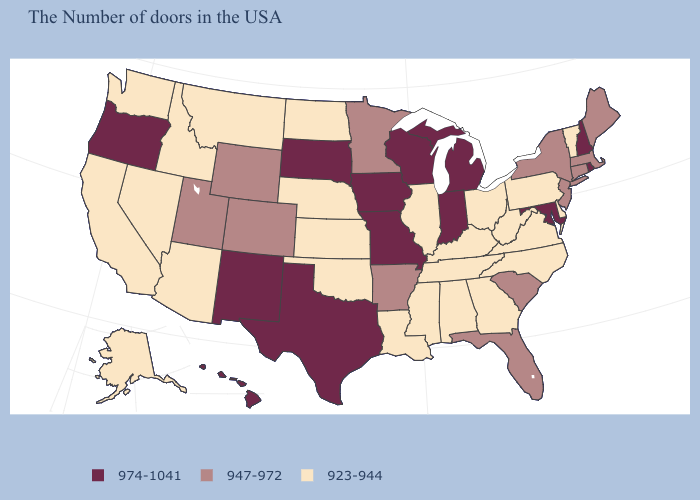Which states have the highest value in the USA?
Concise answer only. Rhode Island, New Hampshire, Maryland, Michigan, Indiana, Wisconsin, Missouri, Iowa, Texas, South Dakota, New Mexico, Oregon, Hawaii. What is the value of California?
Short answer required. 923-944. Does Washington have the highest value in the USA?
Give a very brief answer. No. What is the value of Kansas?
Write a very short answer. 923-944. What is the value of Nebraska?
Give a very brief answer. 923-944. Among the states that border Pennsylvania , which have the lowest value?
Be succinct. Delaware, West Virginia, Ohio. Among the states that border Washington , does Idaho have the lowest value?
Short answer required. Yes. What is the value of Alaska?
Quick response, please. 923-944. Name the states that have a value in the range 923-944?
Write a very short answer. Vermont, Delaware, Pennsylvania, Virginia, North Carolina, West Virginia, Ohio, Georgia, Kentucky, Alabama, Tennessee, Illinois, Mississippi, Louisiana, Kansas, Nebraska, Oklahoma, North Dakota, Montana, Arizona, Idaho, Nevada, California, Washington, Alaska. Among the states that border New York , which have the highest value?
Be succinct. Massachusetts, Connecticut, New Jersey. Name the states that have a value in the range 974-1041?
Give a very brief answer. Rhode Island, New Hampshire, Maryland, Michigan, Indiana, Wisconsin, Missouri, Iowa, Texas, South Dakota, New Mexico, Oregon, Hawaii. What is the highest value in the USA?
Be succinct. 974-1041. What is the highest value in the South ?
Be succinct. 974-1041. Does the first symbol in the legend represent the smallest category?
Write a very short answer. No. 